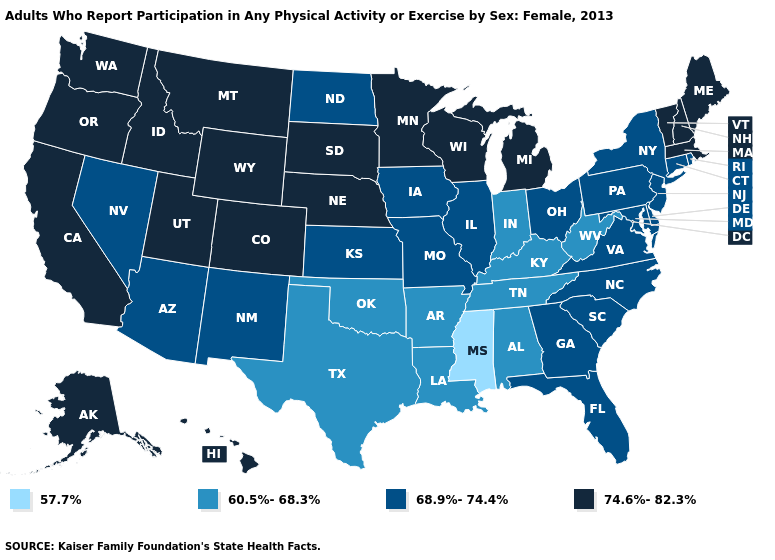What is the lowest value in states that border Maine?
Concise answer only. 74.6%-82.3%. Name the states that have a value in the range 68.9%-74.4%?
Keep it brief. Arizona, Connecticut, Delaware, Florida, Georgia, Illinois, Iowa, Kansas, Maryland, Missouri, Nevada, New Jersey, New Mexico, New York, North Carolina, North Dakota, Ohio, Pennsylvania, Rhode Island, South Carolina, Virginia. Is the legend a continuous bar?
Answer briefly. No. Name the states that have a value in the range 74.6%-82.3%?
Keep it brief. Alaska, California, Colorado, Hawaii, Idaho, Maine, Massachusetts, Michigan, Minnesota, Montana, Nebraska, New Hampshire, Oregon, South Dakota, Utah, Vermont, Washington, Wisconsin, Wyoming. Does Mississippi have the lowest value in the South?
Answer briefly. Yes. Name the states that have a value in the range 74.6%-82.3%?
Answer briefly. Alaska, California, Colorado, Hawaii, Idaho, Maine, Massachusetts, Michigan, Minnesota, Montana, Nebraska, New Hampshire, Oregon, South Dakota, Utah, Vermont, Washington, Wisconsin, Wyoming. What is the highest value in the Northeast ?
Short answer required. 74.6%-82.3%. What is the value of Maine?
Give a very brief answer. 74.6%-82.3%. Does Mississippi have the lowest value in the USA?
Be succinct. Yes. Does Idaho have the highest value in the West?
Short answer required. Yes. What is the value of Massachusetts?
Be succinct. 74.6%-82.3%. What is the value of California?
Concise answer only. 74.6%-82.3%. What is the value of North Carolina?
Short answer required. 68.9%-74.4%. Does Wisconsin have the same value as New Jersey?
Keep it brief. No. Among the states that border Oregon , which have the lowest value?
Answer briefly. Nevada. 